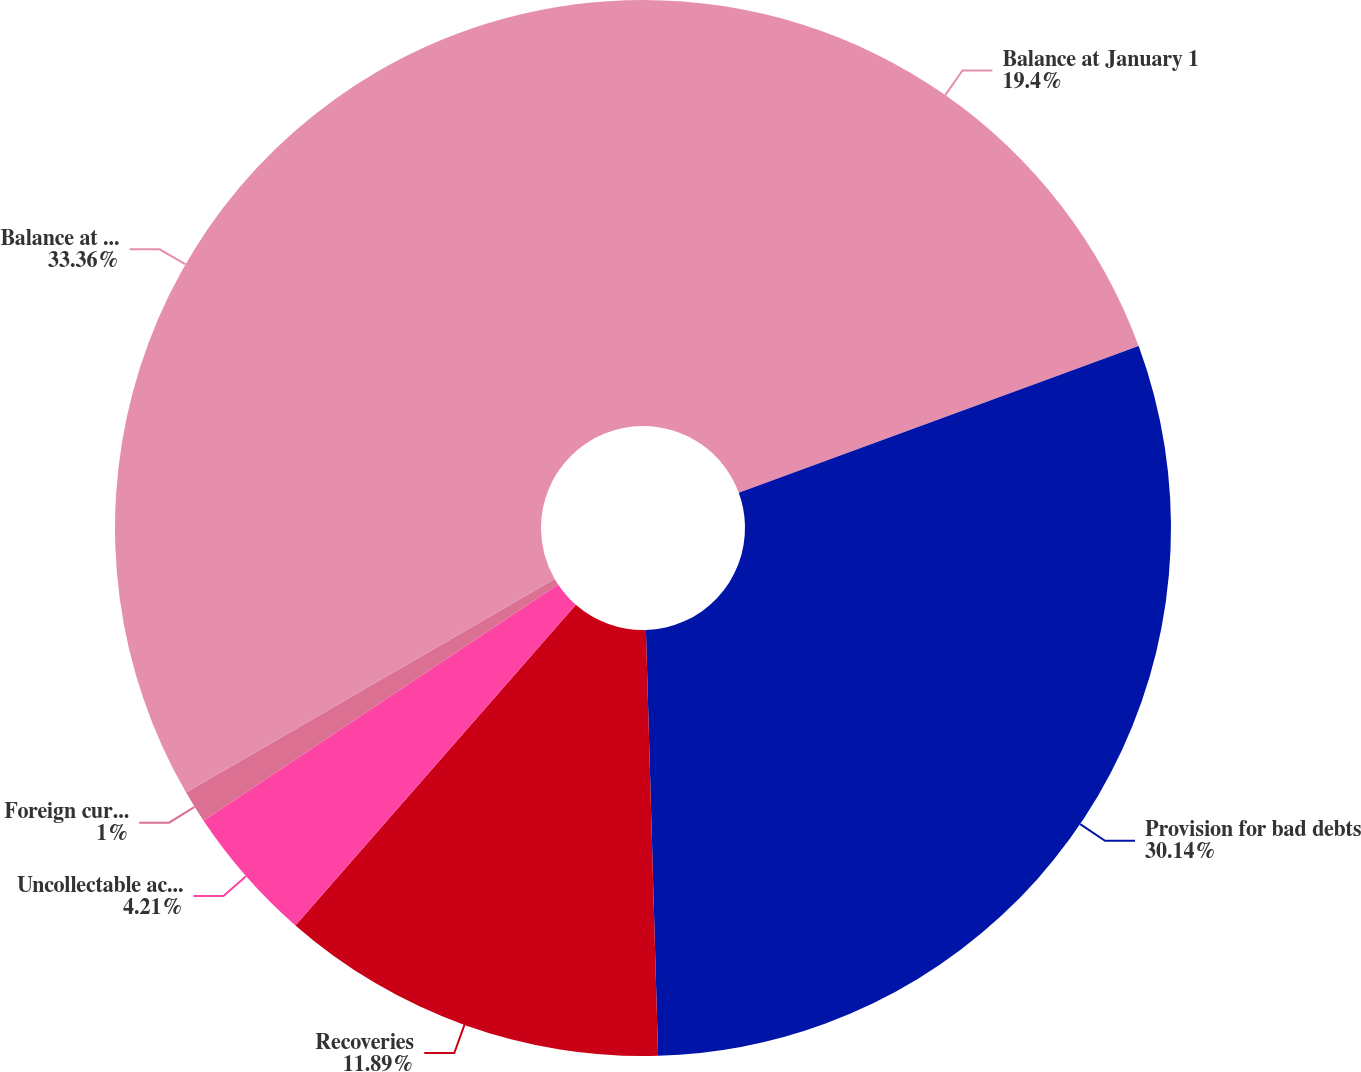Convert chart to OTSL. <chart><loc_0><loc_0><loc_500><loc_500><pie_chart><fcel>Balance at January 1<fcel>Provision for bad debts<fcel>Recoveries<fcel>Uncollectable accounts written<fcel>Foreign currency translation<fcel>Balance at December 31<nl><fcel>19.4%<fcel>30.14%<fcel>11.89%<fcel>4.21%<fcel>1.0%<fcel>33.35%<nl></chart> 